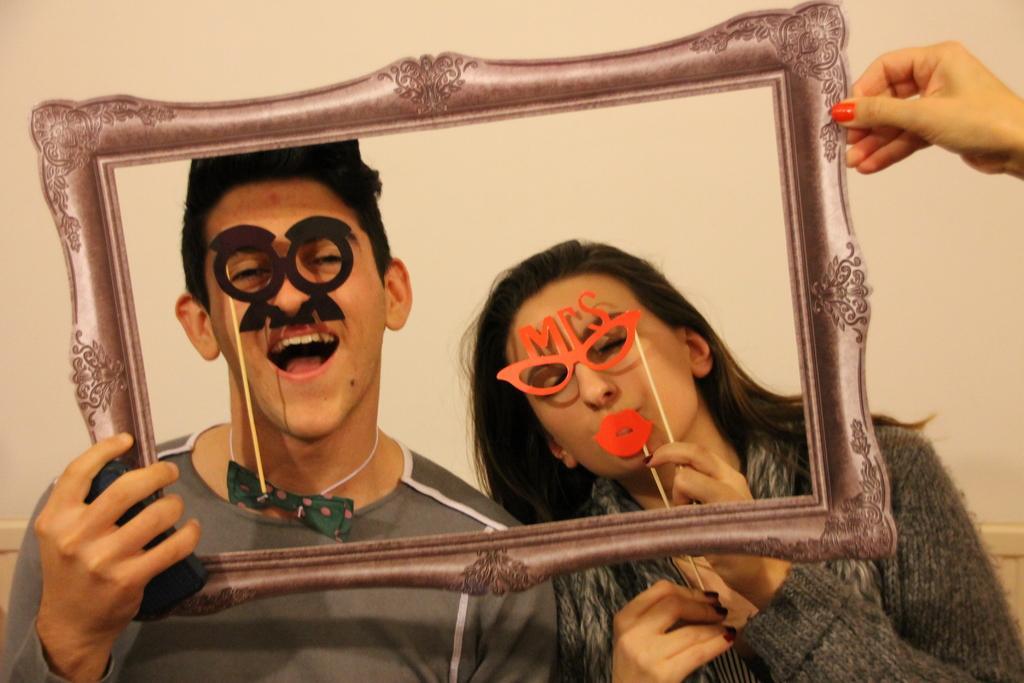Please provide a concise description of this image. In this image these two persons are two persons are standing at bottom of this image and the left side person is holding a frame and there is one other hand at top right corner of this image and there is a wall in the background. 